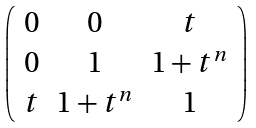<formula> <loc_0><loc_0><loc_500><loc_500>\left ( \begin{array} { c c c } 0 & 0 & t \\ 0 & 1 & 1 + t ^ { n } \\ t & 1 + t ^ { n } & 1 \end{array} \right )</formula> 